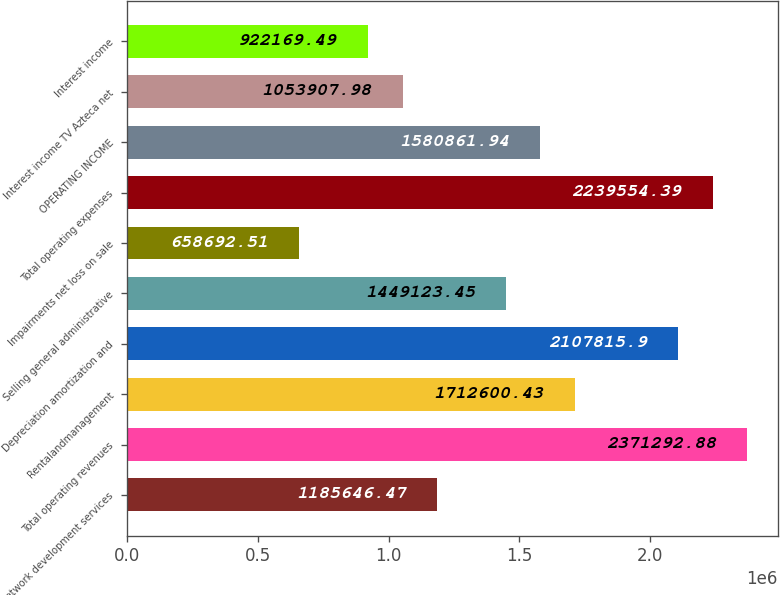<chart> <loc_0><loc_0><loc_500><loc_500><bar_chart><fcel>Network development services<fcel>Total operating revenues<fcel>Rentalandmanagement<fcel>Depreciation amortization and<fcel>Selling general administrative<fcel>Impairments net loss on sale<fcel>Total operating expenses<fcel>OPERATING INCOME<fcel>Interest income TV Azteca net<fcel>Interest income<nl><fcel>1.18565e+06<fcel>2.37129e+06<fcel>1.7126e+06<fcel>2.10782e+06<fcel>1.44912e+06<fcel>658693<fcel>2.23955e+06<fcel>1.58086e+06<fcel>1.05391e+06<fcel>922169<nl></chart> 